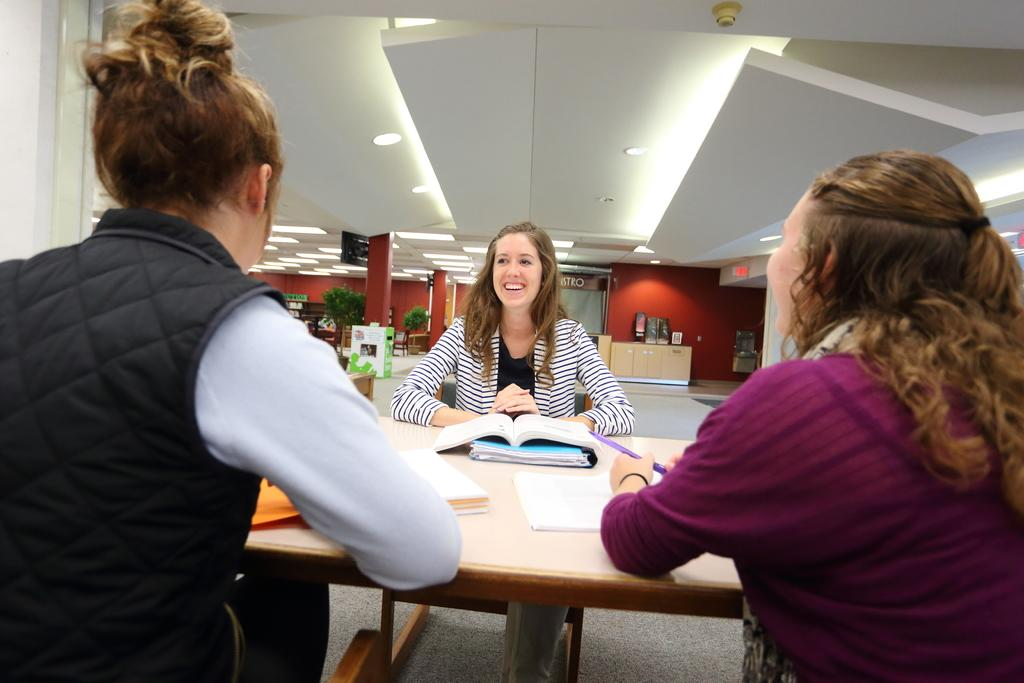What is the main subject in the middle of the image? There is a woman sitting in the middle of the image. What is the woman doing in the image? The woman is laughing. What can be seen at the top of the image? There are lights at the top of the image. Who else is present in the image besides the woman? There are two girls sitting on the left and right sides of the image. What are the girls looking at in the image? The girls are looking at the straight side. Can you tell me how many cans are visible in the image? There are no cans present in the image. What type of question are the girls asking in the image? There is no indication of a question being asked in the image. 